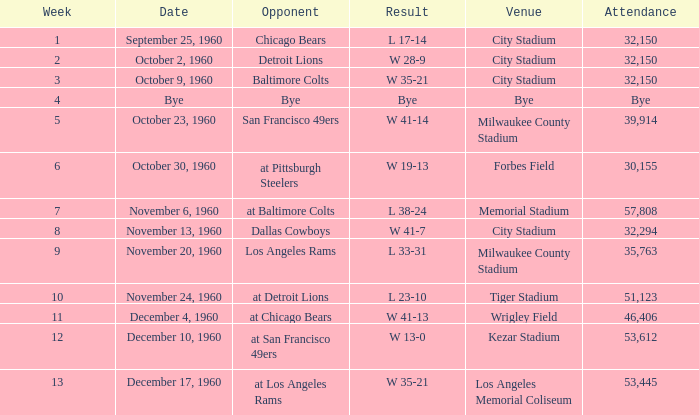Write the full table. {'header': ['Week', 'Date', 'Opponent', 'Result', 'Venue', 'Attendance'], 'rows': [['1', 'September 25, 1960', 'Chicago Bears', 'L 17-14', 'City Stadium', '32,150'], ['2', 'October 2, 1960', 'Detroit Lions', 'W 28-9', 'City Stadium', '32,150'], ['3', 'October 9, 1960', 'Baltimore Colts', 'W 35-21', 'City Stadium', '32,150'], ['4', 'Bye', 'Bye', 'Bye', 'Bye', 'Bye'], ['5', 'October 23, 1960', 'San Francisco 49ers', 'W 41-14', 'Milwaukee County Stadium', '39,914'], ['6', 'October 30, 1960', 'at Pittsburgh Steelers', 'W 19-13', 'Forbes Field', '30,155'], ['7', 'November 6, 1960', 'at Baltimore Colts', 'L 38-24', 'Memorial Stadium', '57,808'], ['8', 'November 13, 1960', 'Dallas Cowboys', 'W 41-7', 'City Stadium', '32,294'], ['9', 'November 20, 1960', 'Los Angeles Rams', 'L 33-31', 'Milwaukee County Stadium', '35,763'], ['10', 'November 24, 1960', 'at Detroit Lions', 'L 23-10', 'Tiger Stadium', '51,123'], ['11', 'December 4, 1960', 'at Chicago Bears', 'W 41-13', 'Wrigley Field', '46,406'], ['12', 'December 10, 1960', 'at San Francisco 49ers', 'W 13-0', 'Kezar Stadium', '53,612'], ['13', 'December 17, 1960', 'at Los Angeles Rams', 'W 35-21', 'Los Angeles Memorial Coliseum', '53,445']]} What was the count of attendees at the tiger stadium? L 23-10. 